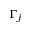<formula> <loc_0><loc_0><loc_500><loc_500>\Gamma _ { j }</formula> 